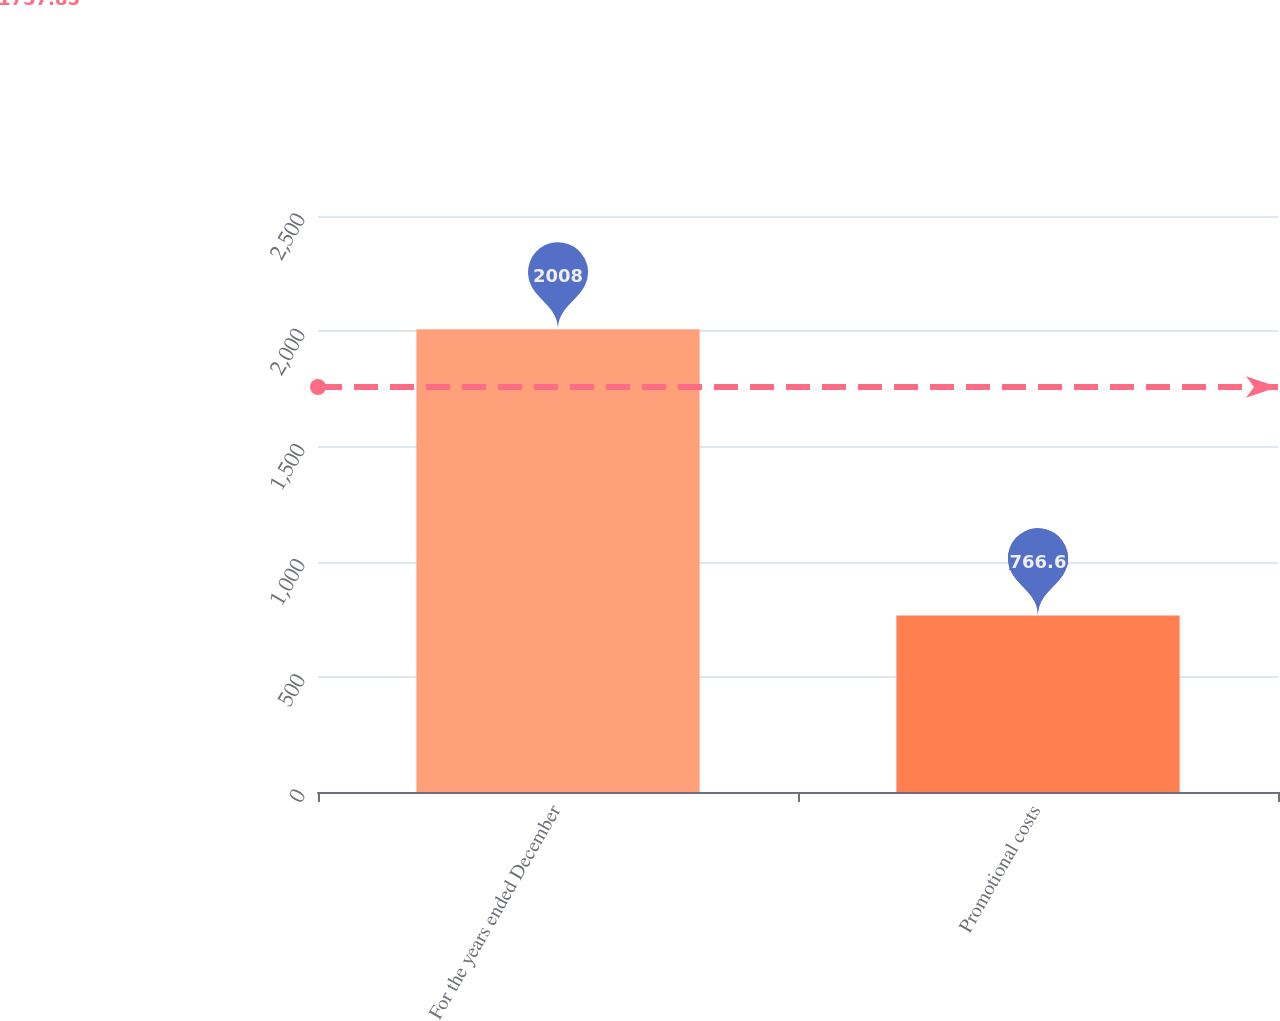<chart> <loc_0><loc_0><loc_500><loc_500><bar_chart><fcel>For the years ended December<fcel>Promotional costs<nl><fcel>2008<fcel>766.6<nl></chart> 